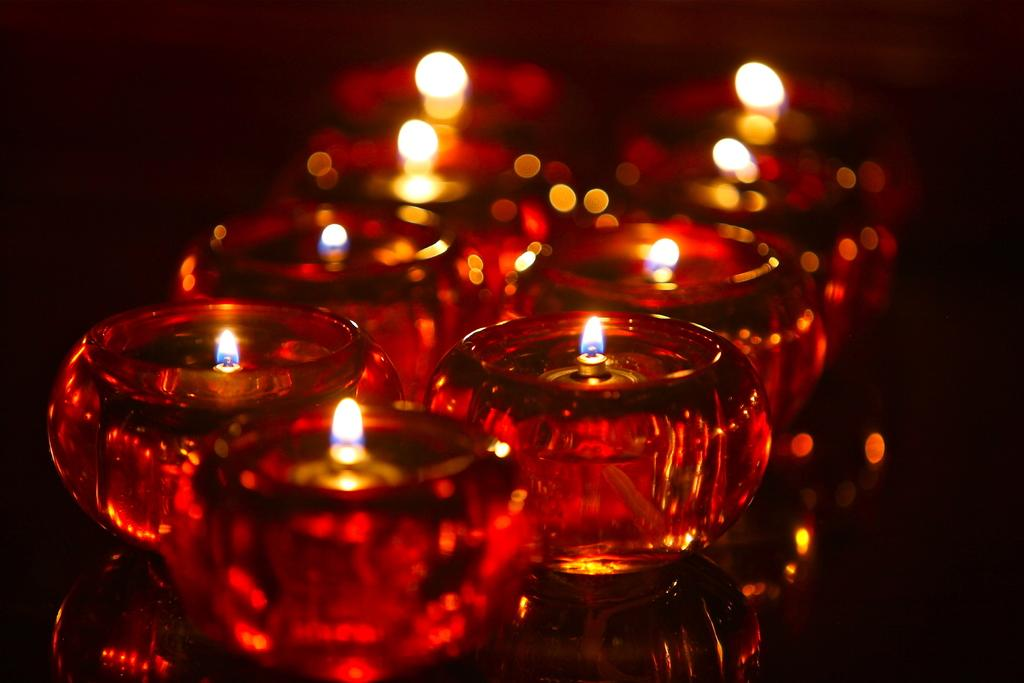What objects are present in the image? There are candles in the image. Can you describe the candles in more detail? Unfortunately, the provided facts do not offer any additional details about the candles. Are there any other objects or elements in the image besides the candles? No, the only information given is that there are candles in the image. What type of horse is depicted in the image? There is no horse present in the image; it only features candles. How many stalks of celery can be seen in the image? There is no celery present in the image; it only features candles. 